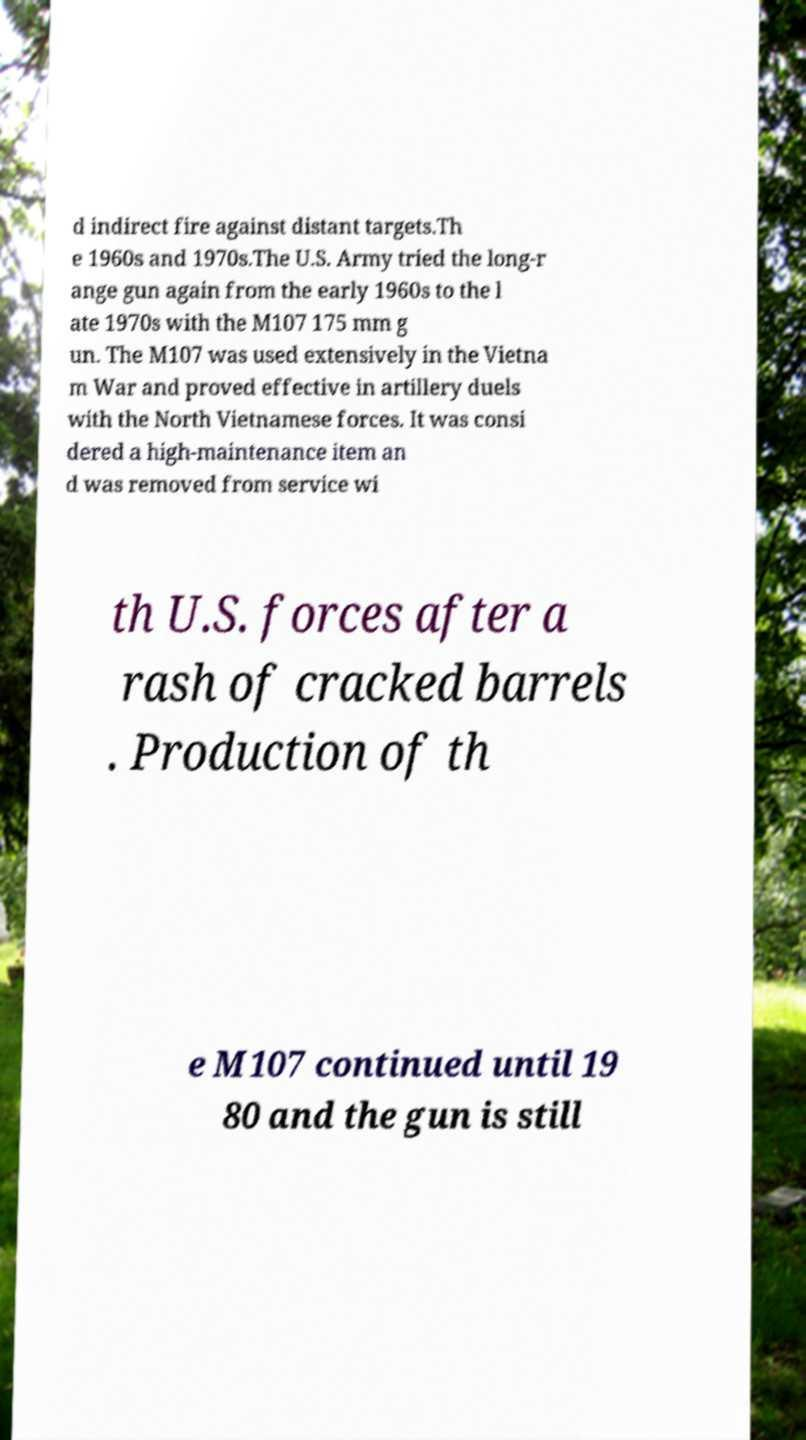There's text embedded in this image that I need extracted. Can you transcribe it verbatim? d indirect fire against distant targets.Th e 1960s and 1970s.The U.S. Army tried the long-r ange gun again from the early 1960s to the l ate 1970s with the M107 175 mm g un. The M107 was used extensively in the Vietna m War and proved effective in artillery duels with the North Vietnamese forces. It was consi dered a high-maintenance item an d was removed from service wi th U.S. forces after a rash of cracked barrels . Production of th e M107 continued until 19 80 and the gun is still 